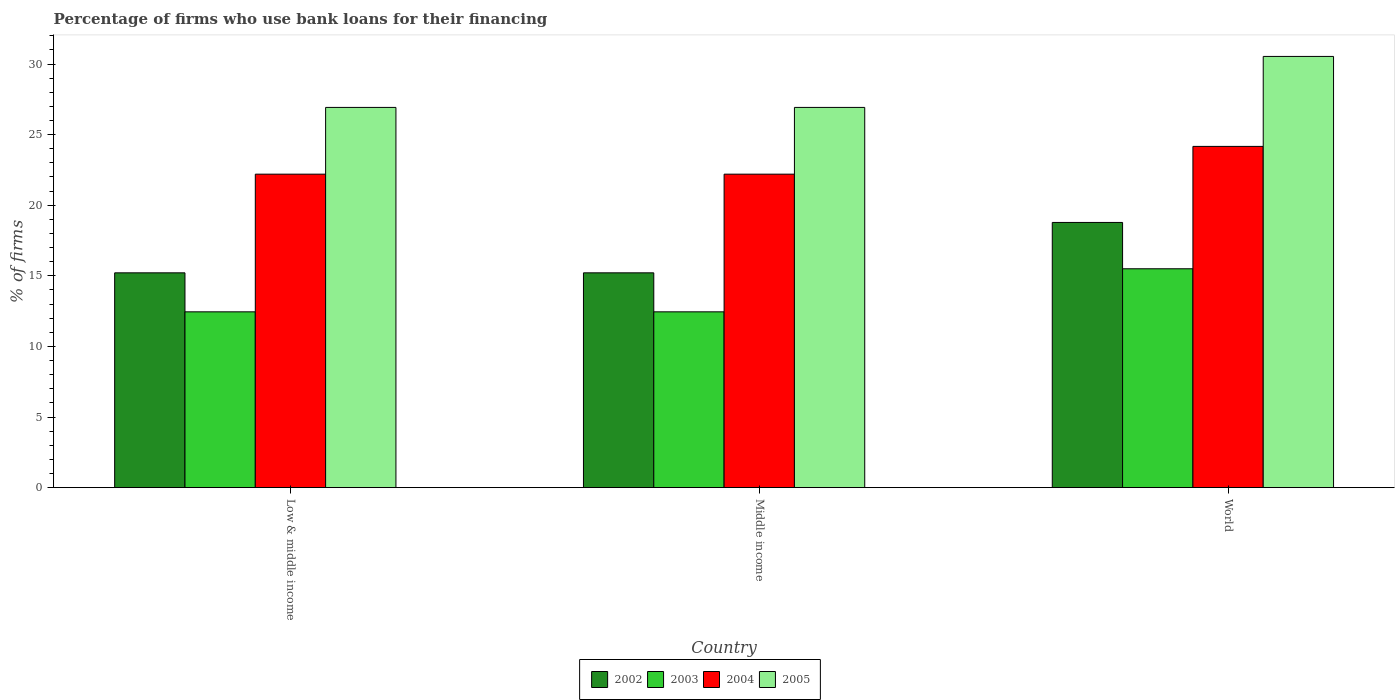How many bars are there on the 3rd tick from the left?
Your answer should be very brief. 4. How many bars are there on the 1st tick from the right?
Provide a short and direct response. 4. What is the label of the 1st group of bars from the left?
Make the answer very short. Low & middle income. In how many cases, is the number of bars for a given country not equal to the number of legend labels?
Your response must be concise. 0. What is the percentage of firms who use bank loans for their financing in 2003 in World?
Your answer should be very brief. 15.5. Across all countries, what is the maximum percentage of firms who use bank loans for their financing in 2004?
Make the answer very short. 24.17. Across all countries, what is the minimum percentage of firms who use bank loans for their financing in 2005?
Your answer should be compact. 26.93. In which country was the percentage of firms who use bank loans for their financing in 2003 minimum?
Make the answer very short. Low & middle income. What is the total percentage of firms who use bank loans for their financing in 2002 in the graph?
Give a very brief answer. 49.21. What is the difference between the percentage of firms who use bank loans for their financing in 2005 in Low & middle income and that in World?
Offer a terse response. -3.61. What is the difference between the percentage of firms who use bank loans for their financing in 2004 in Low & middle income and the percentage of firms who use bank loans for their financing in 2002 in World?
Keep it short and to the point. 3.42. What is the average percentage of firms who use bank loans for their financing in 2002 per country?
Make the answer very short. 16.4. What is the difference between the percentage of firms who use bank loans for their financing of/in 2005 and percentage of firms who use bank loans for their financing of/in 2003 in World?
Give a very brief answer. 15.04. In how many countries, is the percentage of firms who use bank loans for their financing in 2005 greater than 3 %?
Keep it short and to the point. 3. What is the ratio of the percentage of firms who use bank loans for their financing in 2002 in Middle income to that in World?
Provide a short and direct response. 0.81. Is the percentage of firms who use bank loans for their financing in 2004 in Low & middle income less than that in Middle income?
Offer a very short reply. No. What is the difference between the highest and the second highest percentage of firms who use bank loans for their financing in 2002?
Keep it short and to the point. 3.57. What is the difference between the highest and the lowest percentage of firms who use bank loans for their financing in 2004?
Your answer should be compact. 1.97. In how many countries, is the percentage of firms who use bank loans for their financing in 2003 greater than the average percentage of firms who use bank loans for their financing in 2003 taken over all countries?
Ensure brevity in your answer.  1. What does the 4th bar from the left in Low & middle income represents?
Offer a terse response. 2005. Is it the case that in every country, the sum of the percentage of firms who use bank loans for their financing in 2005 and percentage of firms who use bank loans for their financing in 2004 is greater than the percentage of firms who use bank loans for their financing in 2002?
Offer a terse response. Yes. How many bars are there?
Keep it short and to the point. 12. Are all the bars in the graph horizontal?
Provide a succinct answer. No. How many countries are there in the graph?
Offer a very short reply. 3. What is the difference between two consecutive major ticks on the Y-axis?
Give a very brief answer. 5. Are the values on the major ticks of Y-axis written in scientific E-notation?
Your answer should be compact. No. Where does the legend appear in the graph?
Your answer should be very brief. Bottom center. How many legend labels are there?
Provide a succinct answer. 4. What is the title of the graph?
Make the answer very short. Percentage of firms who use bank loans for their financing. Does "1994" appear as one of the legend labels in the graph?
Give a very brief answer. No. What is the label or title of the X-axis?
Provide a short and direct response. Country. What is the label or title of the Y-axis?
Provide a short and direct response. % of firms. What is the % of firms of 2002 in Low & middle income?
Keep it short and to the point. 15.21. What is the % of firms of 2003 in Low & middle income?
Provide a succinct answer. 12.45. What is the % of firms in 2005 in Low & middle income?
Provide a succinct answer. 26.93. What is the % of firms of 2002 in Middle income?
Your answer should be compact. 15.21. What is the % of firms of 2003 in Middle income?
Make the answer very short. 12.45. What is the % of firms in 2005 in Middle income?
Make the answer very short. 26.93. What is the % of firms in 2002 in World?
Offer a terse response. 18.78. What is the % of firms in 2003 in World?
Offer a very short reply. 15.5. What is the % of firms of 2004 in World?
Make the answer very short. 24.17. What is the % of firms of 2005 in World?
Offer a very short reply. 30.54. Across all countries, what is the maximum % of firms in 2002?
Provide a short and direct response. 18.78. Across all countries, what is the maximum % of firms of 2003?
Keep it short and to the point. 15.5. Across all countries, what is the maximum % of firms of 2004?
Make the answer very short. 24.17. Across all countries, what is the maximum % of firms of 2005?
Ensure brevity in your answer.  30.54. Across all countries, what is the minimum % of firms in 2002?
Ensure brevity in your answer.  15.21. Across all countries, what is the minimum % of firms of 2003?
Make the answer very short. 12.45. Across all countries, what is the minimum % of firms in 2005?
Make the answer very short. 26.93. What is the total % of firms in 2002 in the graph?
Offer a very short reply. 49.21. What is the total % of firms of 2003 in the graph?
Your answer should be very brief. 40.4. What is the total % of firms of 2004 in the graph?
Your response must be concise. 68.57. What is the total % of firms of 2005 in the graph?
Your answer should be compact. 84.39. What is the difference between the % of firms in 2002 in Low & middle income and that in Middle income?
Provide a short and direct response. 0. What is the difference between the % of firms of 2003 in Low & middle income and that in Middle income?
Make the answer very short. 0. What is the difference between the % of firms in 2002 in Low & middle income and that in World?
Offer a very short reply. -3.57. What is the difference between the % of firms in 2003 in Low & middle income and that in World?
Provide a short and direct response. -3.05. What is the difference between the % of firms of 2004 in Low & middle income and that in World?
Provide a short and direct response. -1.97. What is the difference between the % of firms in 2005 in Low & middle income and that in World?
Ensure brevity in your answer.  -3.61. What is the difference between the % of firms of 2002 in Middle income and that in World?
Your answer should be compact. -3.57. What is the difference between the % of firms in 2003 in Middle income and that in World?
Keep it short and to the point. -3.05. What is the difference between the % of firms in 2004 in Middle income and that in World?
Provide a short and direct response. -1.97. What is the difference between the % of firms in 2005 in Middle income and that in World?
Give a very brief answer. -3.61. What is the difference between the % of firms in 2002 in Low & middle income and the % of firms in 2003 in Middle income?
Ensure brevity in your answer.  2.76. What is the difference between the % of firms in 2002 in Low & middle income and the % of firms in 2004 in Middle income?
Ensure brevity in your answer.  -6.99. What is the difference between the % of firms of 2002 in Low & middle income and the % of firms of 2005 in Middle income?
Your answer should be very brief. -11.72. What is the difference between the % of firms of 2003 in Low & middle income and the % of firms of 2004 in Middle income?
Make the answer very short. -9.75. What is the difference between the % of firms in 2003 in Low & middle income and the % of firms in 2005 in Middle income?
Offer a very short reply. -14.48. What is the difference between the % of firms in 2004 in Low & middle income and the % of firms in 2005 in Middle income?
Provide a short and direct response. -4.73. What is the difference between the % of firms in 2002 in Low & middle income and the % of firms in 2003 in World?
Your answer should be very brief. -0.29. What is the difference between the % of firms of 2002 in Low & middle income and the % of firms of 2004 in World?
Your answer should be very brief. -8.95. What is the difference between the % of firms in 2002 in Low & middle income and the % of firms in 2005 in World?
Your answer should be very brief. -15.33. What is the difference between the % of firms of 2003 in Low & middle income and the % of firms of 2004 in World?
Give a very brief answer. -11.72. What is the difference between the % of firms in 2003 in Low & middle income and the % of firms in 2005 in World?
Your answer should be very brief. -18.09. What is the difference between the % of firms of 2004 in Low & middle income and the % of firms of 2005 in World?
Give a very brief answer. -8.34. What is the difference between the % of firms in 2002 in Middle income and the % of firms in 2003 in World?
Give a very brief answer. -0.29. What is the difference between the % of firms of 2002 in Middle income and the % of firms of 2004 in World?
Your response must be concise. -8.95. What is the difference between the % of firms of 2002 in Middle income and the % of firms of 2005 in World?
Offer a very short reply. -15.33. What is the difference between the % of firms of 2003 in Middle income and the % of firms of 2004 in World?
Make the answer very short. -11.72. What is the difference between the % of firms in 2003 in Middle income and the % of firms in 2005 in World?
Keep it short and to the point. -18.09. What is the difference between the % of firms in 2004 in Middle income and the % of firms in 2005 in World?
Offer a very short reply. -8.34. What is the average % of firms in 2002 per country?
Make the answer very short. 16.4. What is the average % of firms of 2003 per country?
Make the answer very short. 13.47. What is the average % of firms of 2004 per country?
Make the answer very short. 22.86. What is the average % of firms in 2005 per country?
Offer a very short reply. 28.13. What is the difference between the % of firms of 2002 and % of firms of 2003 in Low & middle income?
Your answer should be very brief. 2.76. What is the difference between the % of firms in 2002 and % of firms in 2004 in Low & middle income?
Provide a succinct answer. -6.99. What is the difference between the % of firms of 2002 and % of firms of 2005 in Low & middle income?
Your answer should be compact. -11.72. What is the difference between the % of firms in 2003 and % of firms in 2004 in Low & middle income?
Make the answer very short. -9.75. What is the difference between the % of firms of 2003 and % of firms of 2005 in Low & middle income?
Ensure brevity in your answer.  -14.48. What is the difference between the % of firms in 2004 and % of firms in 2005 in Low & middle income?
Keep it short and to the point. -4.73. What is the difference between the % of firms in 2002 and % of firms in 2003 in Middle income?
Ensure brevity in your answer.  2.76. What is the difference between the % of firms of 2002 and % of firms of 2004 in Middle income?
Your answer should be very brief. -6.99. What is the difference between the % of firms of 2002 and % of firms of 2005 in Middle income?
Your answer should be compact. -11.72. What is the difference between the % of firms in 2003 and % of firms in 2004 in Middle income?
Keep it short and to the point. -9.75. What is the difference between the % of firms of 2003 and % of firms of 2005 in Middle income?
Offer a terse response. -14.48. What is the difference between the % of firms in 2004 and % of firms in 2005 in Middle income?
Provide a short and direct response. -4.73. What is the difference between the % of firms in 2002 and % of firms in 2003 in World?
Give a very brief answer. 3.28. What is the difference between the % of firms in 2002 and % of firms in 2004 in World?
Offer a very short reply. -5.39. What is the difference between the % of firms of 2002 and % of firms of 2005 in World?
Keep it short and to the point. -11.76. What is the difference between the % of firms of 2003 and % of firms of 2004 in World?
Your answer should be very brief. -8.67. What is the difference between the % of firms in 2003 and % of firms in 2005 in World?
Keep it short and to the point. -15.04. What is the difference between the % of firms in 2004 and % of firms in 2005 in World?
Ensure brevity in your answer.  -6.37. What is the ratio of the % of firms in 2002 in Low & middle income to that in Middle income?
Your answer should be very brief. 1. What is the ratio of the % of firms of 2004 in Low & middle income to that in Middle income?
Ensure brevity in your answer.  1. What is the ratio of the % of firms of 2002 in Low & middle income to that in World?
Provide a succinct answer. 0.81. What is the ratio of the % of firms of 2003 in Low & middle income to that in World?
Offer a very short reply. 0.8. What is the ratio of the % of firms of 2004 in Low & middle income to that in World?
Make the answer very short. 0.92. What is the ratio of the % of firms in 2005 in Low & middle income to that in World?
Your response must be concise. 0.88. What is the ratio of the % of firms in 2002 in Middle income to that in World?
Make the answer very short. 0.81. What is the ratio of the % of firms in 2003 in Middle income to that in World?
Your answer should be very brief. 0.8. What is the ratio of the % of firms of 2004 in Middle income to that in World?
Offer a terse response. 0.92. What is the ratio of the % of firms of 2005 in Middle income to that in World?
Ensure brevity in your answer.  0.88. What is the difference between the highest and the second highest % of firms in 2002?
Make the answer very short. 3.57. What is the difference between the highest and the second highest % of firms in 2003?
Provide a short and direct response. 3.05. What is the difference between the highest and the second highest % of firms in 2004?
Ensure brevity in your answer.  1.97. What is the difference between the highest and the second highest % of firms in 2005?
Ensure brevity in your answer.  3.61. What is the difference between the highest and the lowest % of firms in 2002?
Your answer should be very brief. 3.57. What is the difference between the highest and the lowest % of firms in 2003?
Offer a terse response. 3.05. What is the difference between the highest and the lowest % of firms of 2004?
Keep it short and to the point. 1.97. What is the difference between the highest and the lowest % of firms in 2005?
Provide a succinct answer. 3.61. 